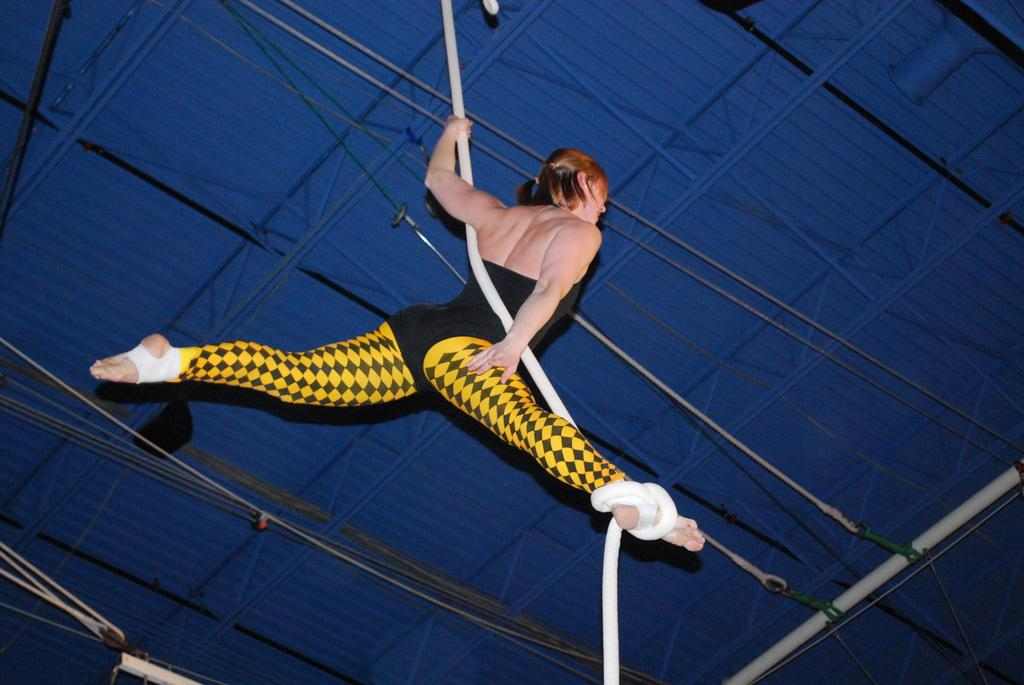What is the person in the image doing? The person is hanging on a rope in the image. What can be seen in the background of the image? There are support beams and additional ropes visible in the background of the image. What type of bushes can be seen in the image? There are no bushes present in the image. How many steps does the person need to take to reach the ground? The image does not provide information about the person's distance from the ground or the presence of steps, so it cannot be determined. 